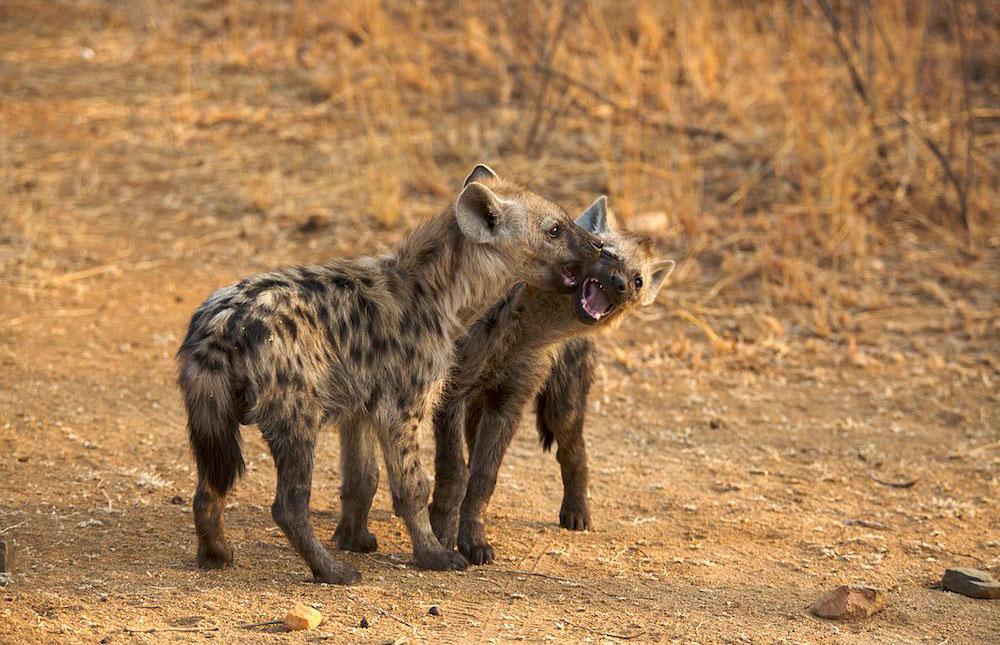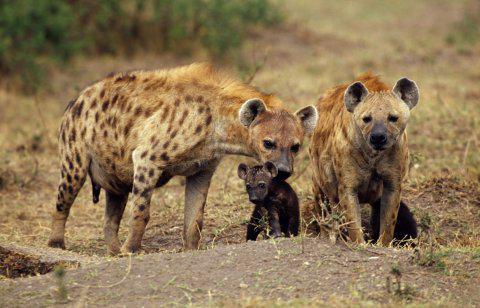The first image is the image on the left, the second image is the image on the right. Examine the images to the left and right. Is the description "Each image contains one hyena, and the hyena on the right has its head and body turned mostly forward, with its neck not raised higher than its shoulders." accurate? Answer yes or no. No. The first image is the image on the left, the second image is the image on the right. Assess this claim about the two images: "There is only one hyena that is standing in each image.". Correct or not? Answer yes or no. No. 